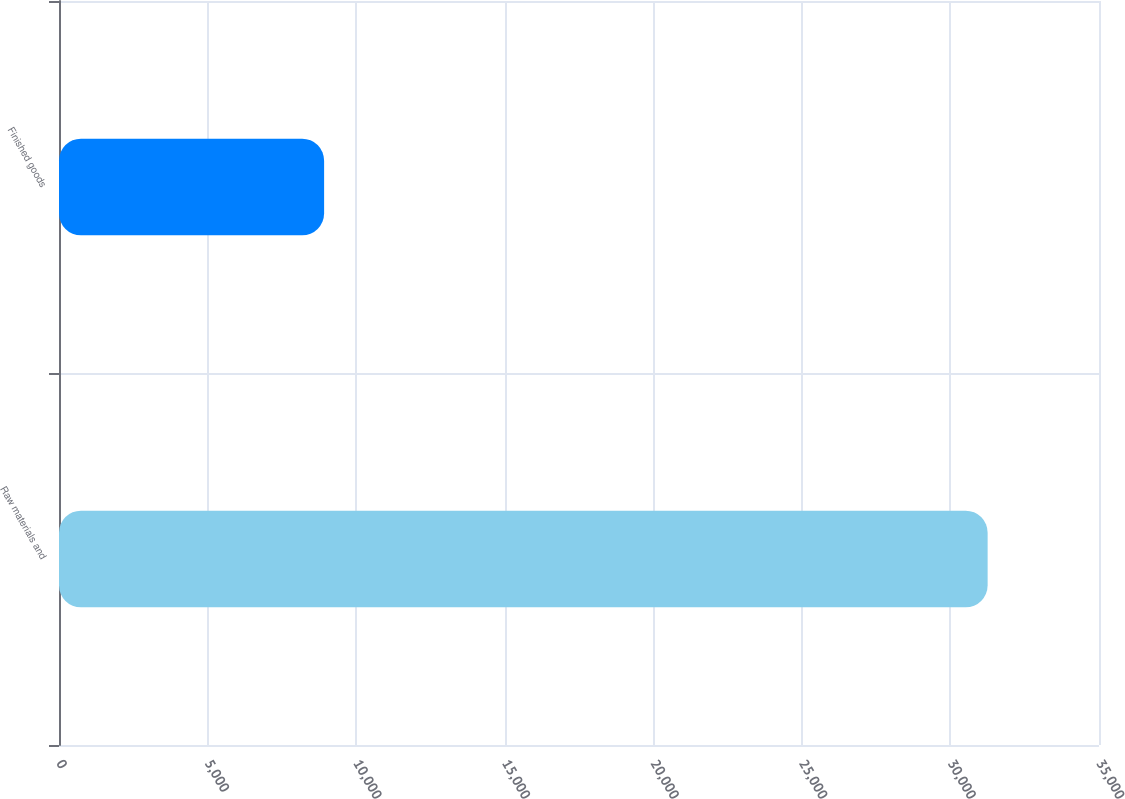Convert chart. <chart><loc_0><loc_0><loc_500><loc_500><bar_chart><fcel>Raw materials and<fcel>Finished goods<nl><fcel>31252<fcel>8922<nl></chart> 